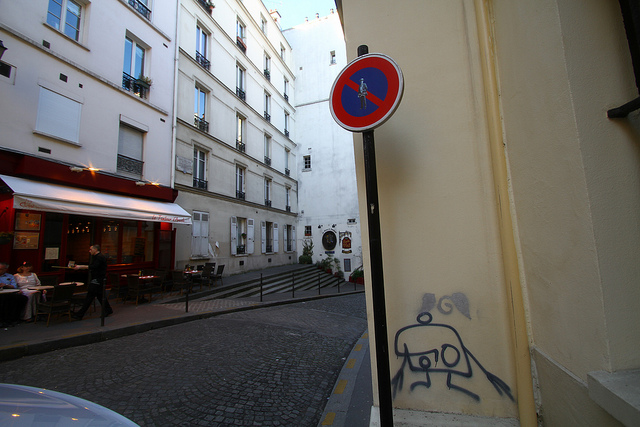<image>Who is on the bench? It is unknown who is on the bench. It could be a woman, 2 people, or no one. Who is on the bench? I don't know who is on the bench. It can be 'no 1', 'unknown', 'drawing', 'woman' or '2 people'. 